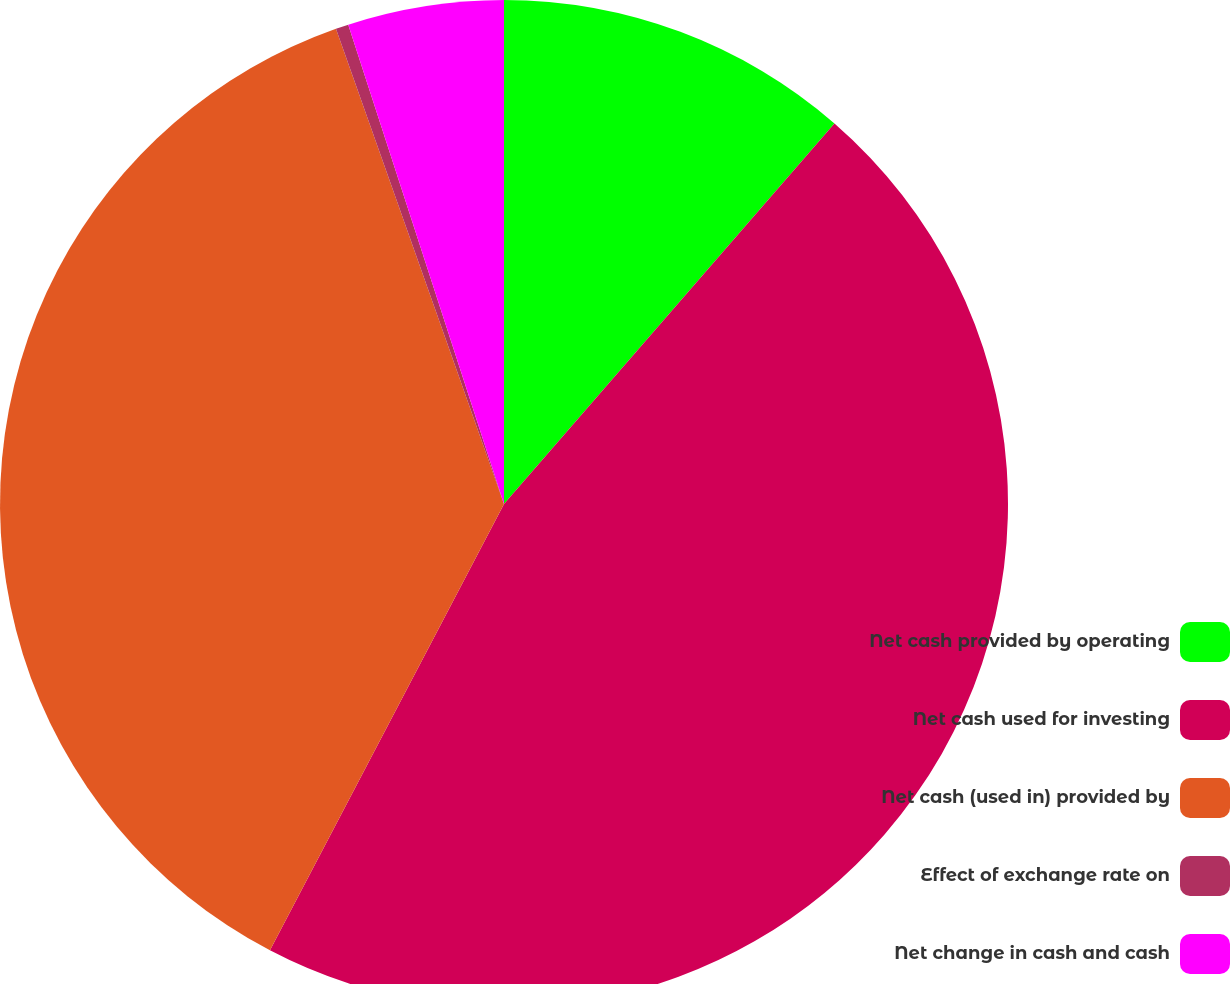<chart> <loc_0><loc_0><loc_500><loc_500><pie_chart><fcel>Net cash provided by operating<fcel>Net cash used for investing<fcel>Net cash (used in) provided by<fcel>Effect of exchange rate on<fcel>Net change in cash and cash<nl><fcel>11.38%<fcel>46.3%<fcel>36.9%<fcel>0.41%<fcel>5.0%<nl></chart> 